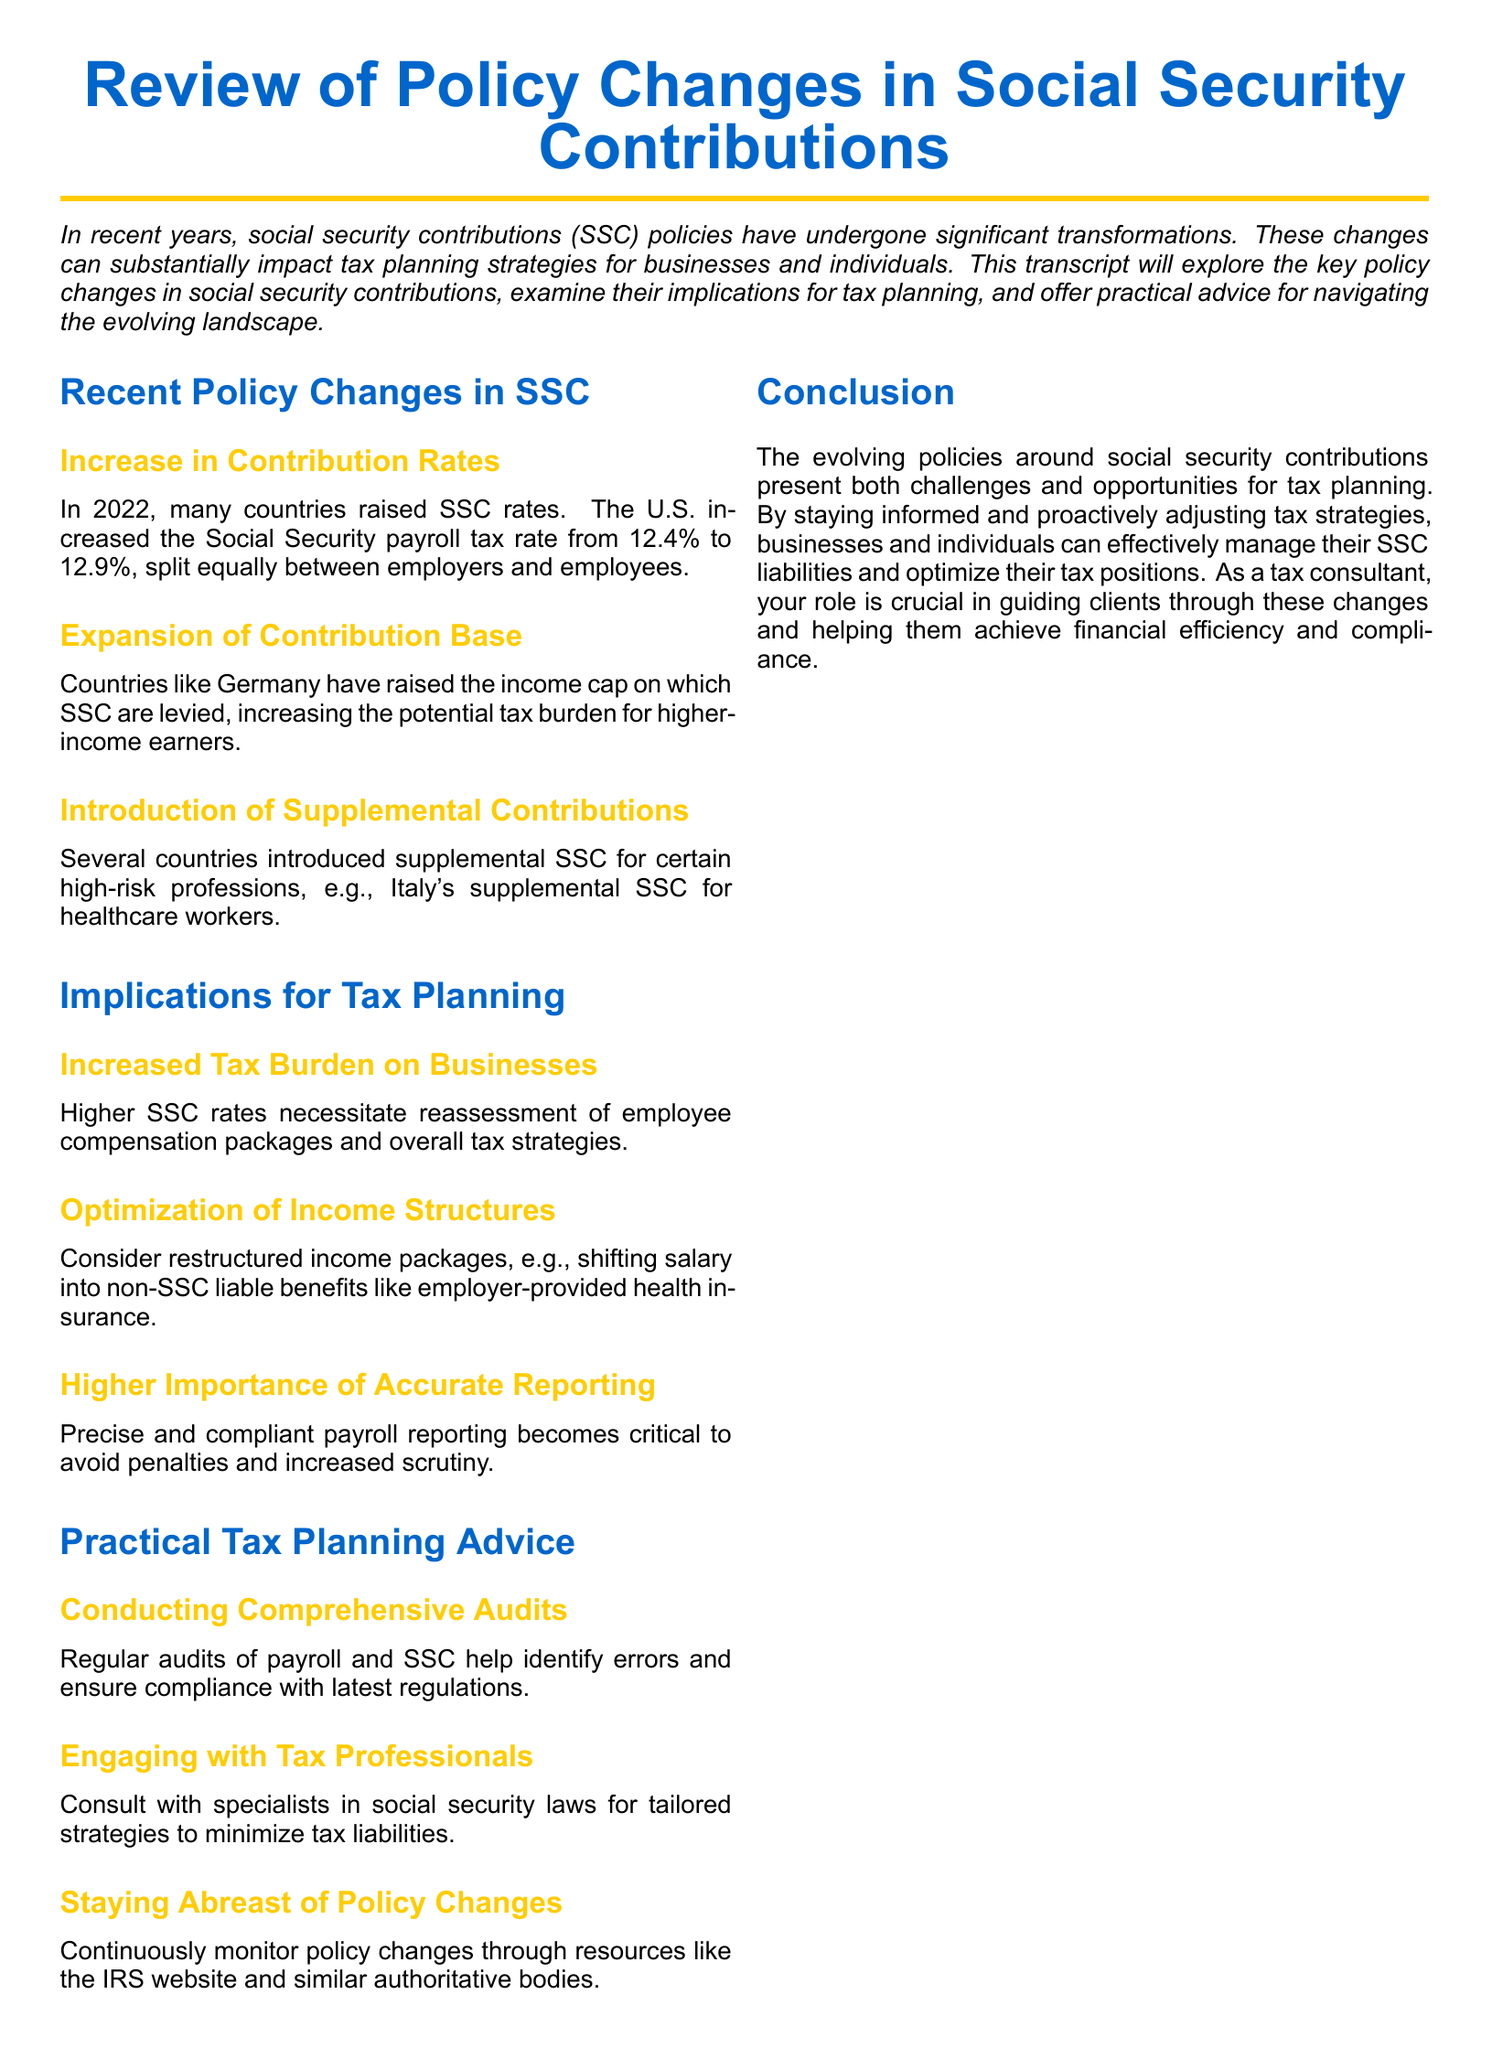What was the U.S. Social Security payroll tax rate increase in 2022? The U.S. increased the Social Security payroll tax rate from 12.4% to 12.9% in 2022.
Answer: 12.9% What has Germany done regarding the contribution base? Germany has raised the income cap on which SSC are levied.
Answer: Raised the income cap What is a newly introduced contribution type in some countries? Several countries introduced supplemental SSC for certain high-risk professions.
Answer: Supplemental contributions How do higher SSC rates affect businesses? Higher SSC rates necessitate reassessment of employee compensation packages and overall tax strategies.
Answer: Increased tax burden on businesses What tax planning strategy is suggested for optimizing income structures? Shifting salary into non-SSC liable benefits like employer-provided health insurance is suggested.
Answer: Restructured income packages What is critical to avoid penalties under new SSC regulations? Accurate and compliant payroll reporting is critical to avoid penalties and increased scrutiny.
Answer: Accurate reporting What type of audits should be conducted regularly? Regular audits of payroll and SSC help identify errors and ensure compliance with latest regulations.
Answer: Comprehensive audits Who should be engaged for tailored tax strategies? Consult with specialists in social security laws for tailored strategies.
Answer: Tax professionals What is essential to manage SSC liabilities effectively? Continuously monitor policy changes through resources like the IRS website.
Answer: Staying abreast of policy changes 